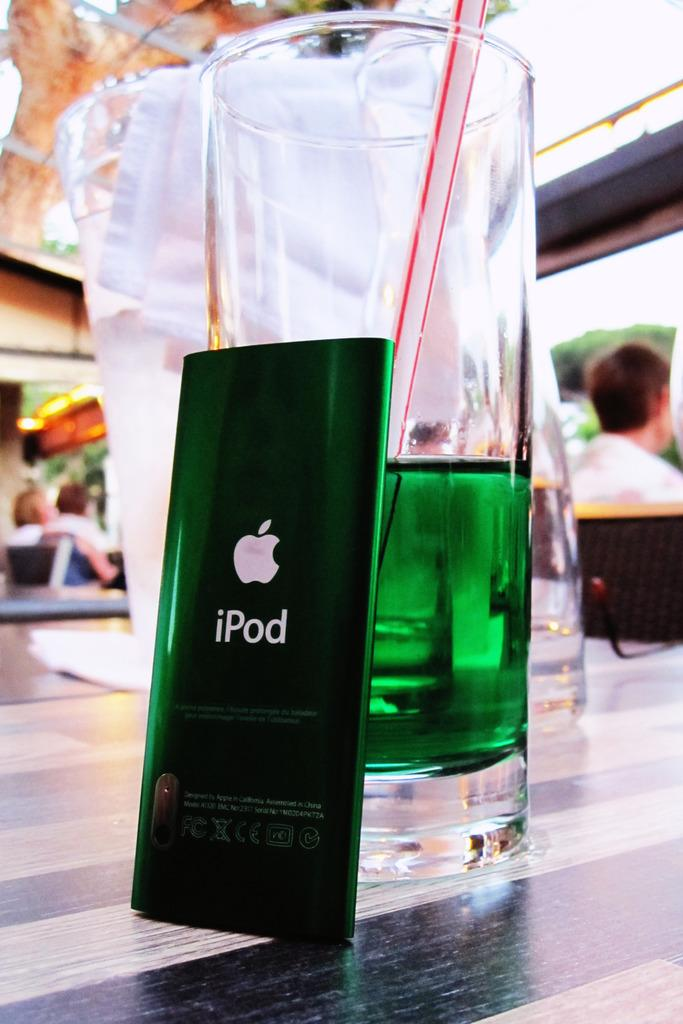Provide a one-sentence caption for the provided image. An iPod is sitting next to a glass with a green liquid in it. 